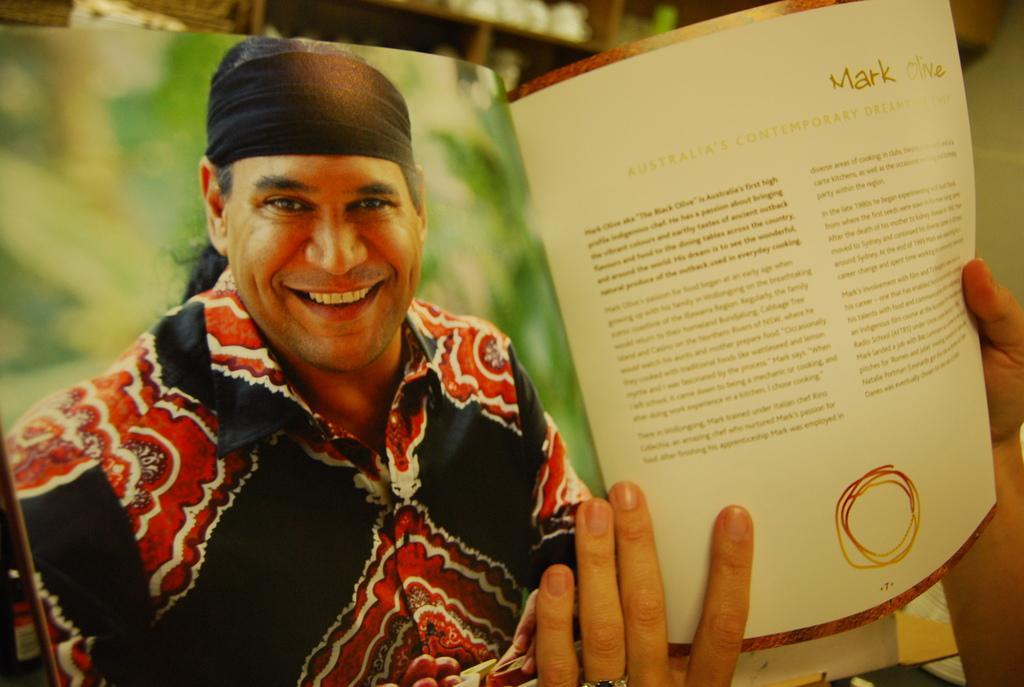Can you describe this image briefly? In this image we can see a person holding a book. On the book something is written and also there is an image of a man smiling. In the background it is blur. 